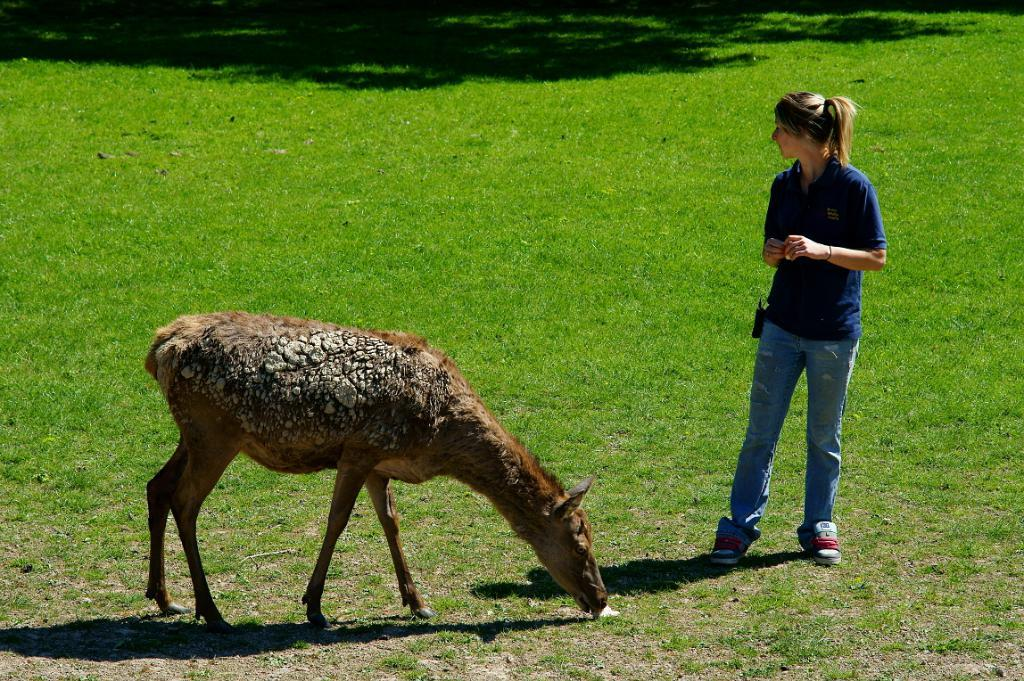What type of animal is in the image? There is an animal in the image, but the specific type cannot be determined from the provided facts. What is on the right side of the image? There is a person on the right side of the image. What is the person doing in the image? The person is standing in the image. What is the person wearing in the image? The person is wearing clothes in the image. What type of ground is visible in the image? There is grass on the ground in the image. What type of approval is the person giving to the animal in the image? There is no indication in the image that the person is giving any type of approval to the animal, as the person's actions or expressions are not described. 